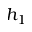<formula> <loc_0><loc_0><loc_500><loc_500>h _ { 1 }</formula> 